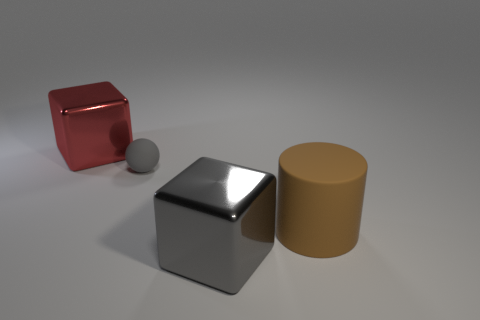What is the material of the red block?
Offer a very short reply. Metal. How many things are either large metal things that are right of the red object or large shiny blocks behind the gray matte ball?
Make the answer very short. 2. How many other objects are the same color as the cylinder?
Provide a succinct answer. 0. There is a big brown rubber thing; does it have the same shape as the big red thing behind the big gray thing?
Offer a very short reply. No. Are there fewer blocks that are in front of the red metal thing than red cubes that are right of the brown cylinder?
Give a very brief answer. No. What is the material of the other large object that is the same shape as the gray metal thing?
Keep it short and to the point. Metal. Is there anything else that is made of the same material as the brown object?
Your answer should be compact. Yes. Is the color of the sphere the same as the matte cylinder?
Your response must be concise. No. What is the shape of the large thing that is the same material as the big red cube?
Your answer should be compact. Cube. How many big gray metallic objects have the same shape as the large red shiny object?
Provide a succinct answer. 1. 